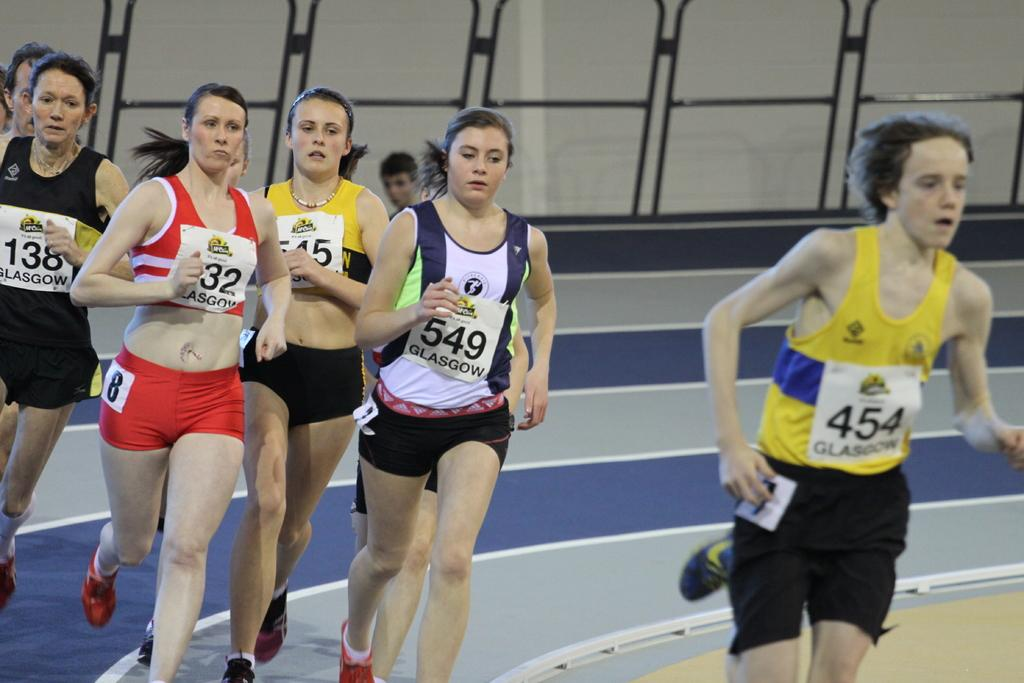<image>
Provide a brief description of the given image. Women running a track, the woman in front displaying the number 454 